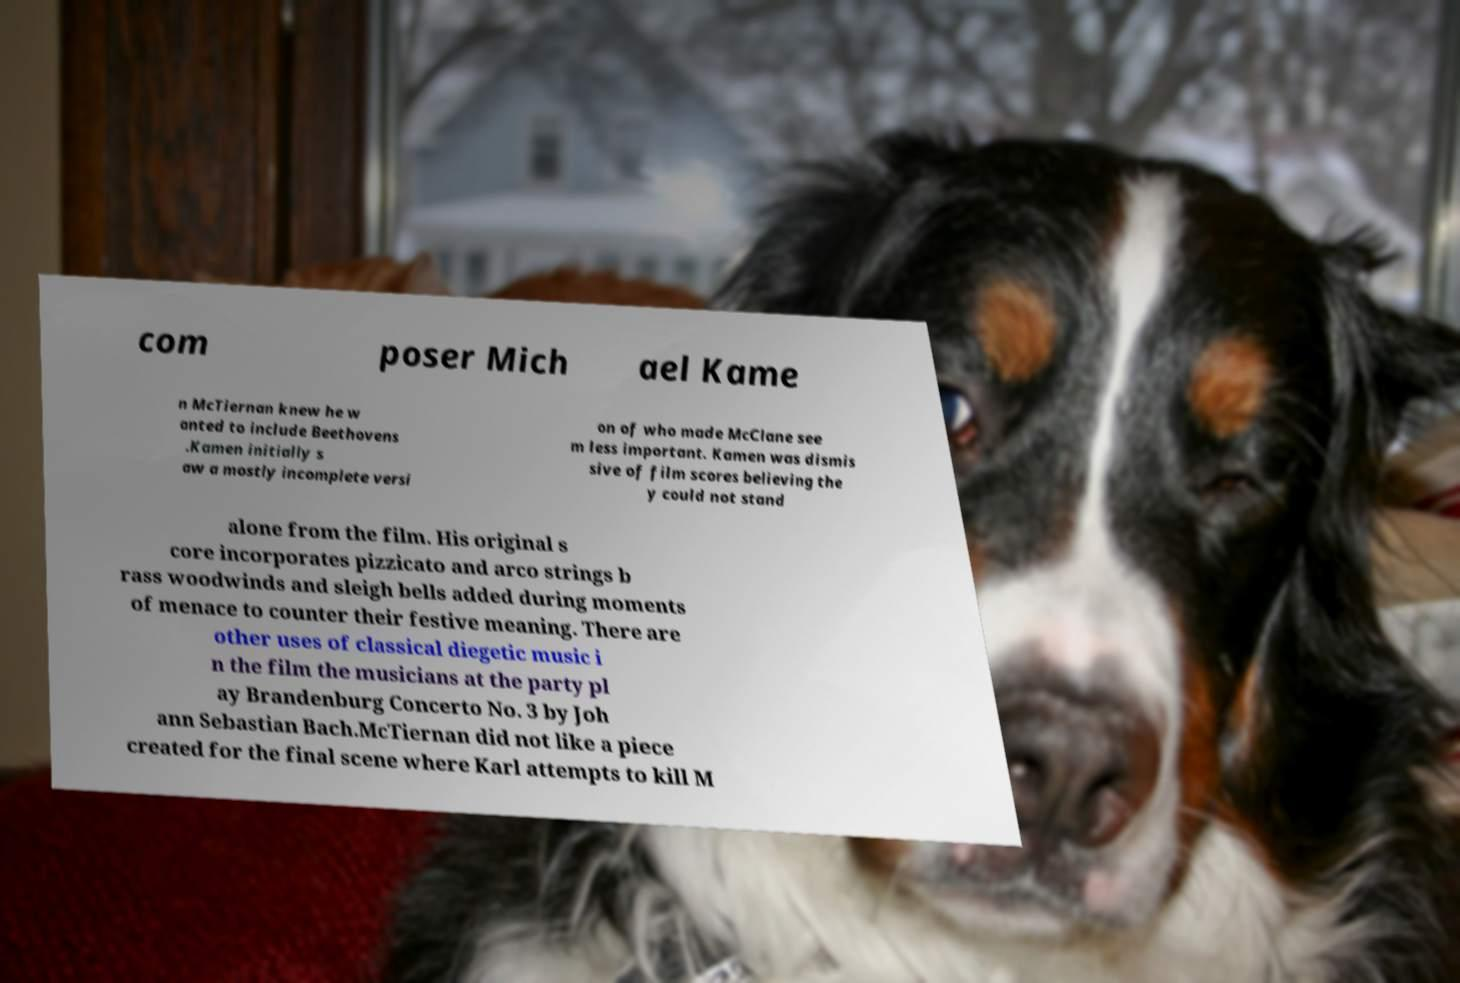Please identify and transcribe the text found in this image. com poser Mich ael Kame n McTiernan knew he w anted to include Beethovens .Kamen initially s aw a mostly incomplete versi on of who made McClane see m less important. Kamen was dismis sive of film scores believing the y could not stand alone from the film. His original s core incorporates pizzicato and arco strings b rass woodwinds and sleigh bells added during moments of menace to counter their festive meaning. There are other uses of classical diegetic music i n the film the musicians at the party pl ay Brandenburg Concerto No. 3 by Joh ann Sebastian Bach.McTiernan did not like a piece created for the final scene where Karl attempts to kill M 